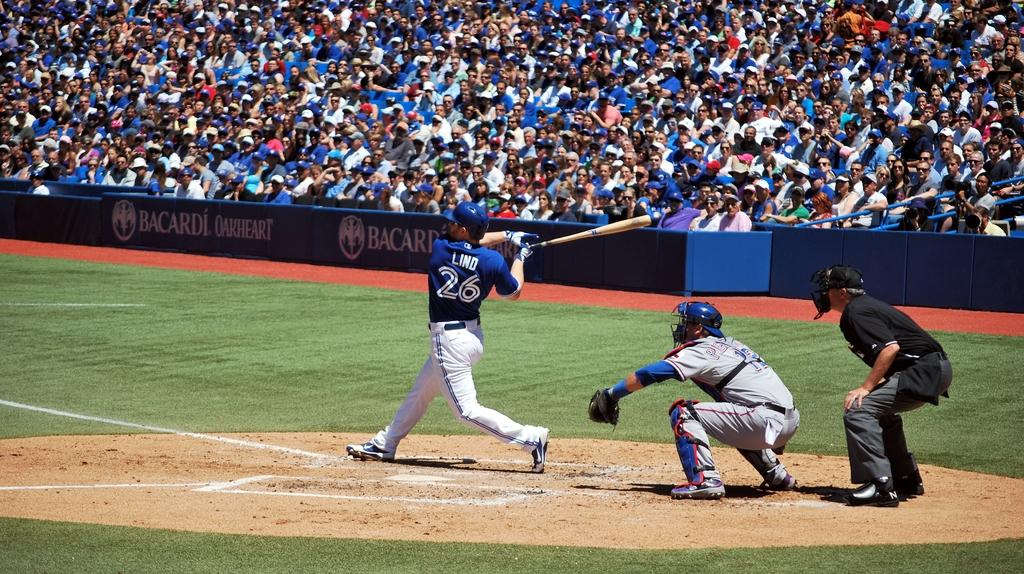<image>
Present a compact description of the photo's key features. A baseball player with LIND on the back of his shirt swings his bat. 